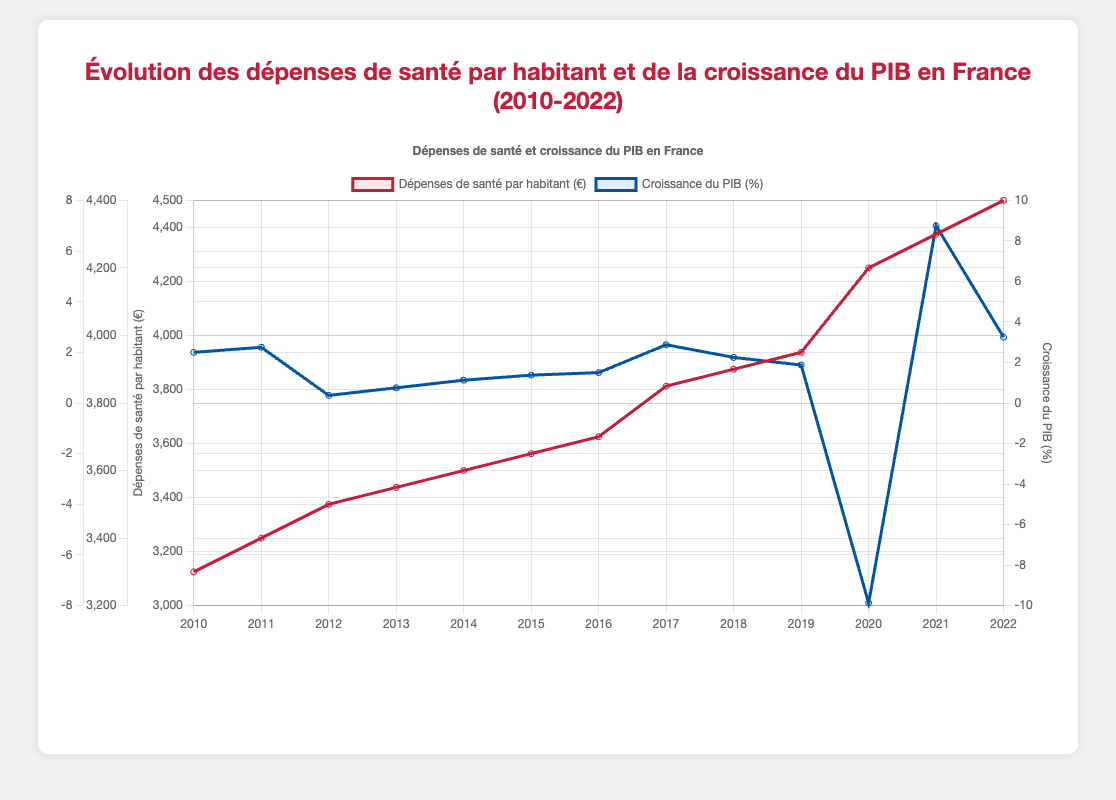What's the highest annual healthcare expenditure per capita shown on the graph? The figure shows that the highest annual healthcare expenditure per capita is represented by the highest point of the red line. This occurs in the year 2022, with a value of 4400 euros.
Answer: 4400 euros In which year did the GDP growth rate drop below -5%? Observing the blue line on the graph, the only year where the GDP growth rate drops below -5% is the year 2020.
Answer: 2020 What is the average annual healthcare expenditure per capita between 2010 and 2022? To find the average, sum all the healthcare expenditure values and divide by the number of years: (3300 + 3400 + 3500 + 3550 + 3600 + 3650 + 3700 + 3850 + 3900 + 3950 + 4200 + 4300 + 4400) / 13 = 3793.08 euros
Answer: 3793.08 euros Which year shows the largest gap between annual healthcare expenditure per capita and GDP growth rate? The largest gap can be found by calculating the absolute difference between the two lines' values for each year. In 2020, the healthcare expenditure was 4200 euros, and the GDP growth was -7.9%, giving an absolute difference of 4200 - (-7.9)= 4200 + 7.9 = 4207.9, which is the largest.
Answer: 2020 How did the annual healthcare expenditure per capita change from 2019 to 2020? From 2019 to 2020, the expenditure increased from 3950 euros to 4200 euros. The change is calculated as 4200 - 3950 = 250 euros.
Answer: Increased by 250 euros What is the difference between the highest and lowest GDP growth rates shown on the graph? The highest GDP growth rate is 7.0% (2021) and the lowest is -7.9% (2020). The difference is calculated as 7.0 - (-7.9) = 7.0 + 7.9 = 14.9%.
Answer: 14.9% In which year did the annual healthcare expenditure per capita first reach and exceed 4000 euros? Looking at the red line, the annual healthcare expenditure per capita first exceeded 4000 euros in 2020, when it reached 4200 euros.
Answer: 2020 Which year had a similar level of GDP growth rate to 2013? In 2013, the GDP growth rate was 0.6%. The next similar value is observed in 2014, when the GDP growth rate is 0.9%.
Answer: 2014 How much did the GDP growth rate increase from 2020 to 2021? From 2020 to 2021, the GDP growth rate increased from -7.9% to 7.0%. The increase is calculated as 7.0 - (-7.9) = 7.0 + 7.9 = 14.9%.
Answer: 14.9% What color represents the GDP growth rate on the graph? On the graph, the GDP growth rate is represented by the blue line.
Answer: Blue 